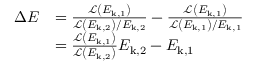<formula> <loc_0><loc_0><loc_500><loc_500>\begin{array} { r l } { \Delta E } & { = \frac { \mathcal { L } \left ( E _ { k , 1 } \right ) } { \mathcal { L } \left ( E _ { k , 2 } \right ) / E _ { k , 2 } } - \frac { \mathcal { L } \left ( E _ { k , 1 } \right ) } { \mathcal { L } \left ( E _ { k , 1 } \right ) / E _ { k , 1 } } } \\ & { = \frac { \mathcal { L } \left ( E _ { k , 1 } \right ) } { \mathcal { L } \left ( E _ { k , 2 } \right ) } E _ { k , 2 } - E _ { k , 1 } } \end{array}</formula> 